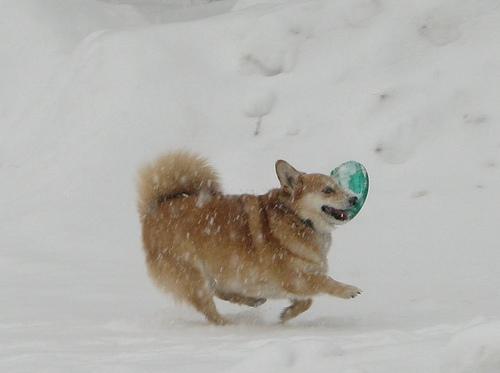Is this dog probably cold?
Keep it brief. Yes. Is the frisbee in the dog's mouth?
Quick response, please. Yes. What color is the dog?
Concise answer only. Brown. 